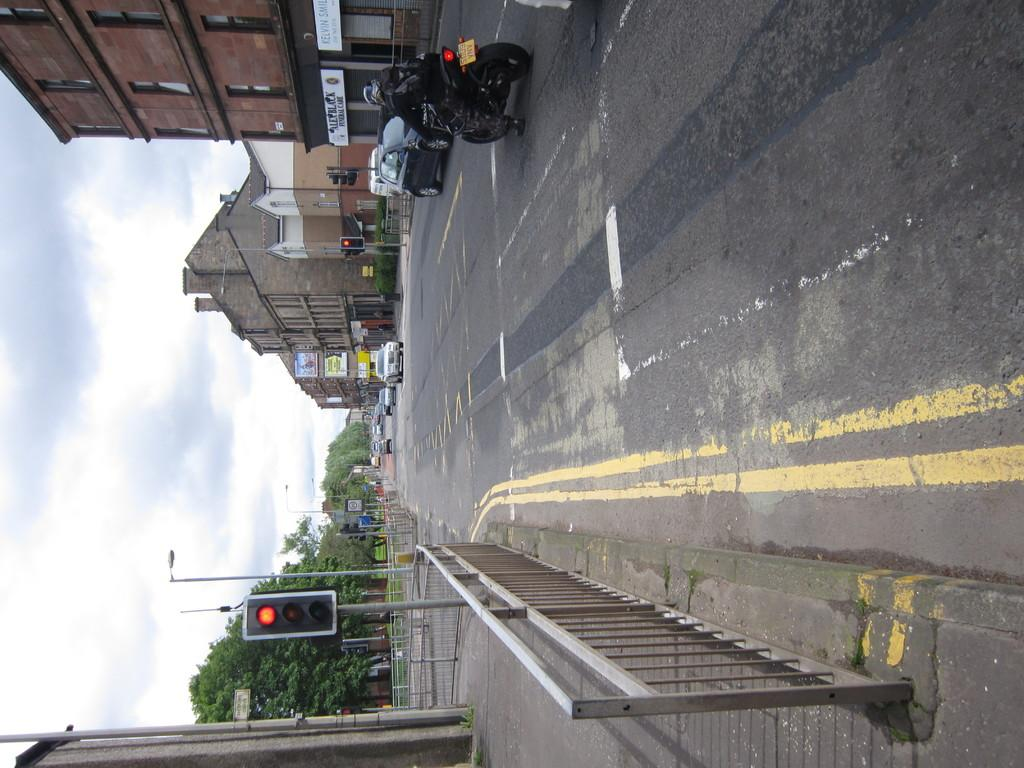What is located in the foreground of the image? There is a fence and traffic signals in the foreground of the image. What can be seen on the road in the foreground of the image? Vehicles are visible on the road in the foreground of the image. What is visible in the background of the image? There are buildings, trees, and the sky visible in the background of the image. Can you describe the time of day when the image was taken? The image was taken during the day. Where is the goat located in the image? There is no goat present in the image. What type of stove can be seen in the background of the image? There is no stove present in the image. 